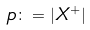<formula> <loc_0><loc_0><loc_500><loc_500>p \colon = | X ^ { + } |</formula> 